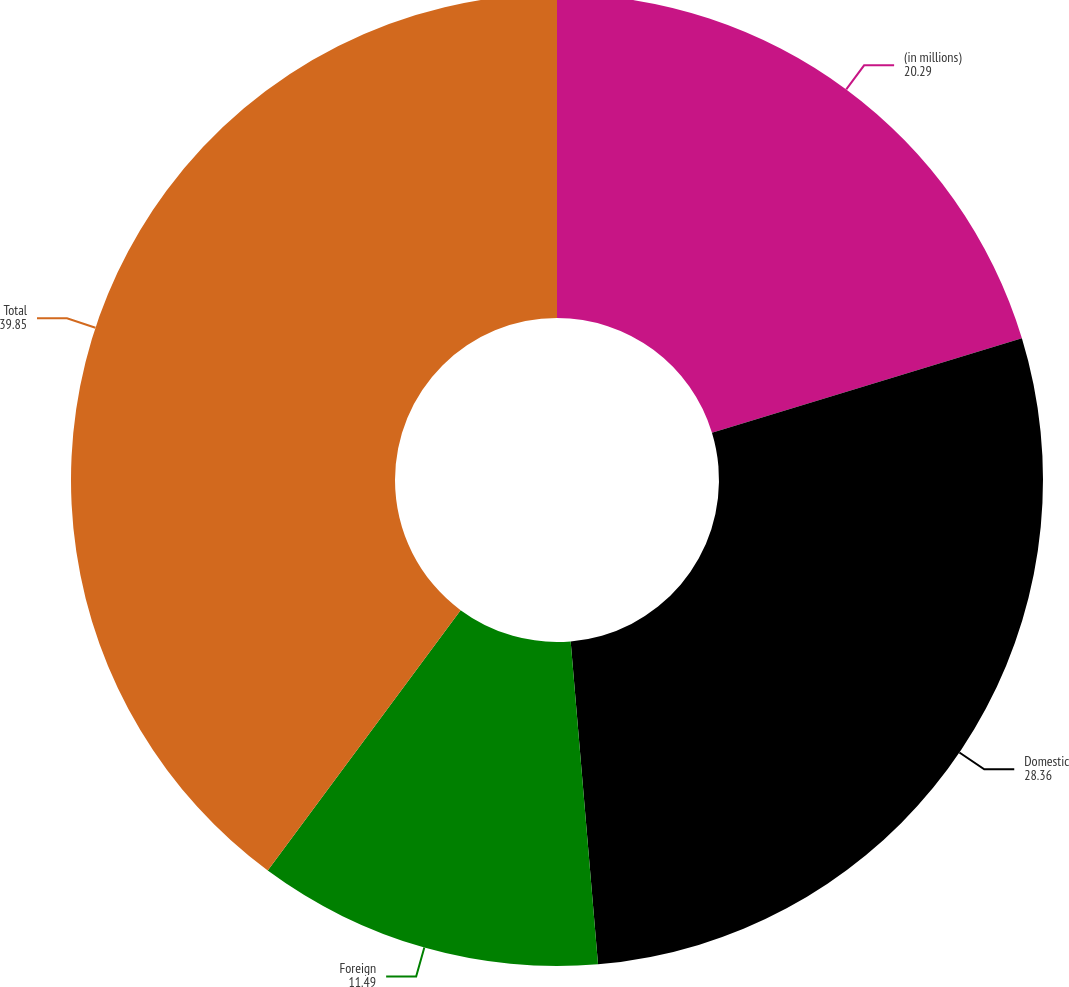Convert chart to OTSL. <chart><loc_0><loc_0><loc_500><loc_500><pie_chart><fcel>(in millions)<fcel>Domestic<fcel>Foreign<fcel>Total<nl><fcel>20.29%<fcel>28.36%<fcel>11.49%<fcel>39.85%<nl></chart> 